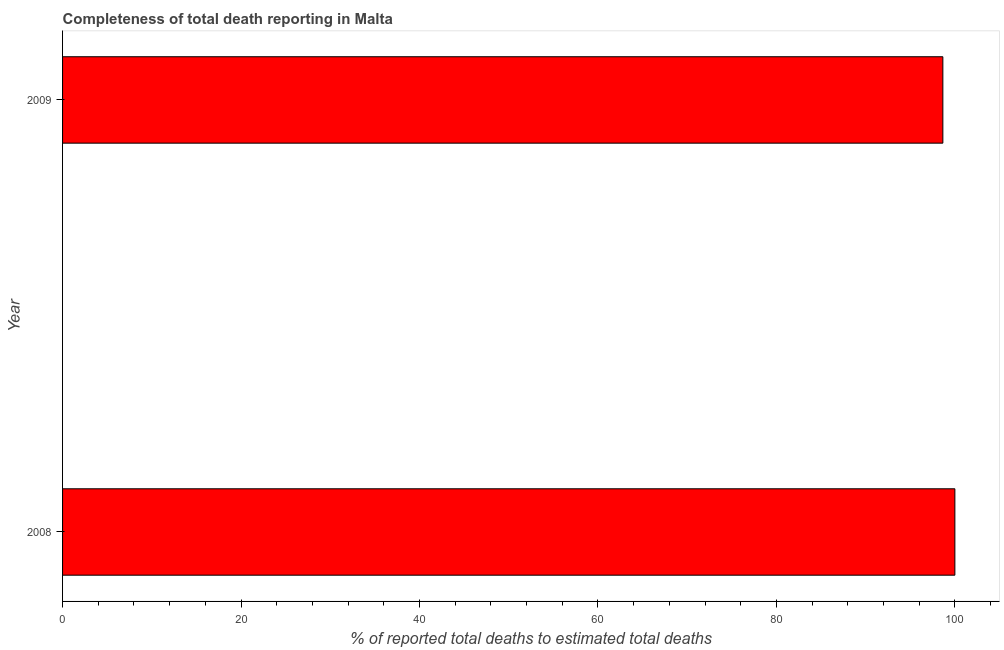Does the graph contain any zero values?
Your response must be concise. No. What is the title of the graph?
Provide a succinct answer. Completeness of total death reporting in Malta. What is the label or title of the X-axis?
Provide a succinct answer. % of reported total deaths to estimated total deaths. What is the completeness of total death reports in 2008?
Keep it short and to the point. 100. Across all years, what is the minimum completeness of total death reports?
Ensure brevity in your answer.  98.65. In which year was the completeness of total death reports maximum?
Offer a terse response. 2008. In which year was the completeness of total death reports minimum?
Provide a succinct answer. 2009. What is the sum of the completeness of total death reports?
Make the answer very short. 198.65. What is the difference between the completeness of total death reports in 2008 and 2009?
Your answer should be compact. 1.35. What is the average completeness of total death reports per year?
Offer a terse response. 99.33. What is the median completeness of total death reports?
Keep it short and to the point. 99.33. In how many years, is the completeness of total death reports greater than 88 %?
Keep it short and to the point. 2. In how many years, is the completeness of total death reports greater than the average completeness of total death reports taken over all years?
Give a very brief answer. 1. How many bars are there?
Your answer should be compact. 2. Are all the bars in the graph horizontal?
Offer a terse response. Yes. How many years are there in the graph?
Offer a very short reply. 2. What is the difference between two consecutive major ticks on the X-axis?
Offer a very short reply. 20. Are the values on the major ticks of X-axis written in scientific E-notation?
Keep it short and to the point. No. What is the % of reported total deaths to estimated total deaths in 2009?
Provide a short and direct response. 98.65. What is the difference between the % of reported total deaths to estimated total deaths in 2008 and 2009?
Your answer should be very brief. 1.35. What is the ratio of the % of reported total deaths to estimated total deaths in 2008 to that in 2009?
Your response must be concise. 1.01. 